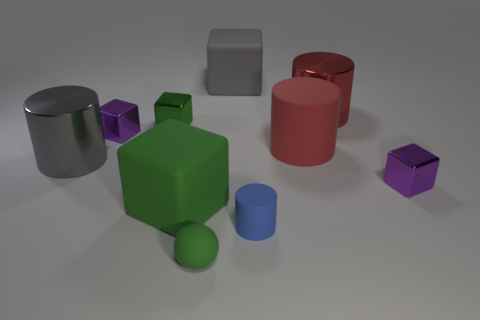Subtract 1 cubes. How many cubes are left? 4 Subtract all gray cubes. How many cubes are left? 4 Subtract all gray cubes. How many cubes are left? 4 Subtract all brown cubes. Subtract all red cylinders. How many cubes are left? 5 Subtract all cylinders. How many objects are left? 6 Add 9 large green objects. How many large green objects are left? 10 Add 5 cyan cubes. How many cyan cubes exist? 5 Subtract 1 red cylinders. How many objects are left? 9 Subtract all tiny green blocks. Subtract all cylinders. How many objects are left? 5 